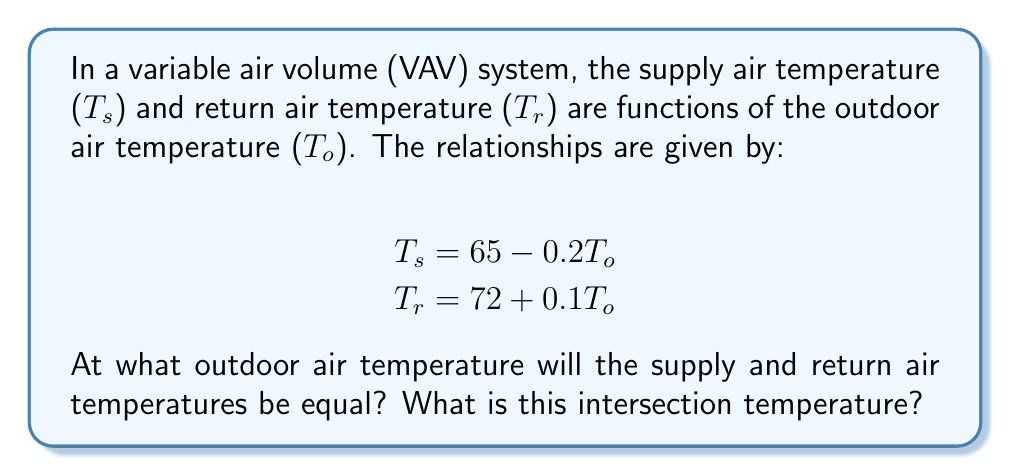Give your solution to this math problem. To find the intersection point, we need to set the two equations equal to each other and solve for $T_o$:

1) Set the equations equal:
   $65 - 0.2T_o = 72 + 0.1T_o$

2) Subtract 65 from both sides:
   $-0.2T_o = 7 + 0.1T_o$

3) Subtract $0.1T_o$ from both sides:
   $-0.3T_o = 7$

4) Divide both sides by -0.3:
   $T_o = -23.33$

5) Now that we know the outdoor temperature at the intersection point, we can calculate the intersection temperature by plugging $T_o$ into either the $T_s$ or $T_r$ equation:

   $T_s = 65 - 0.2(-23.33) = 65 + 4.67 = 69.67$
   
   $T_r = 72 + 0.1(-23.33) = 72 - 2.33 = 69.67$

Thus, the supply and return air temperatures intersect at 69.67°F when the outdoor temperature is -23.33°F.
Answer: The supply and return air temperatures intersect when the outdoor temperature is -23.33°F, and the intersection temperature is 69.67°F. 